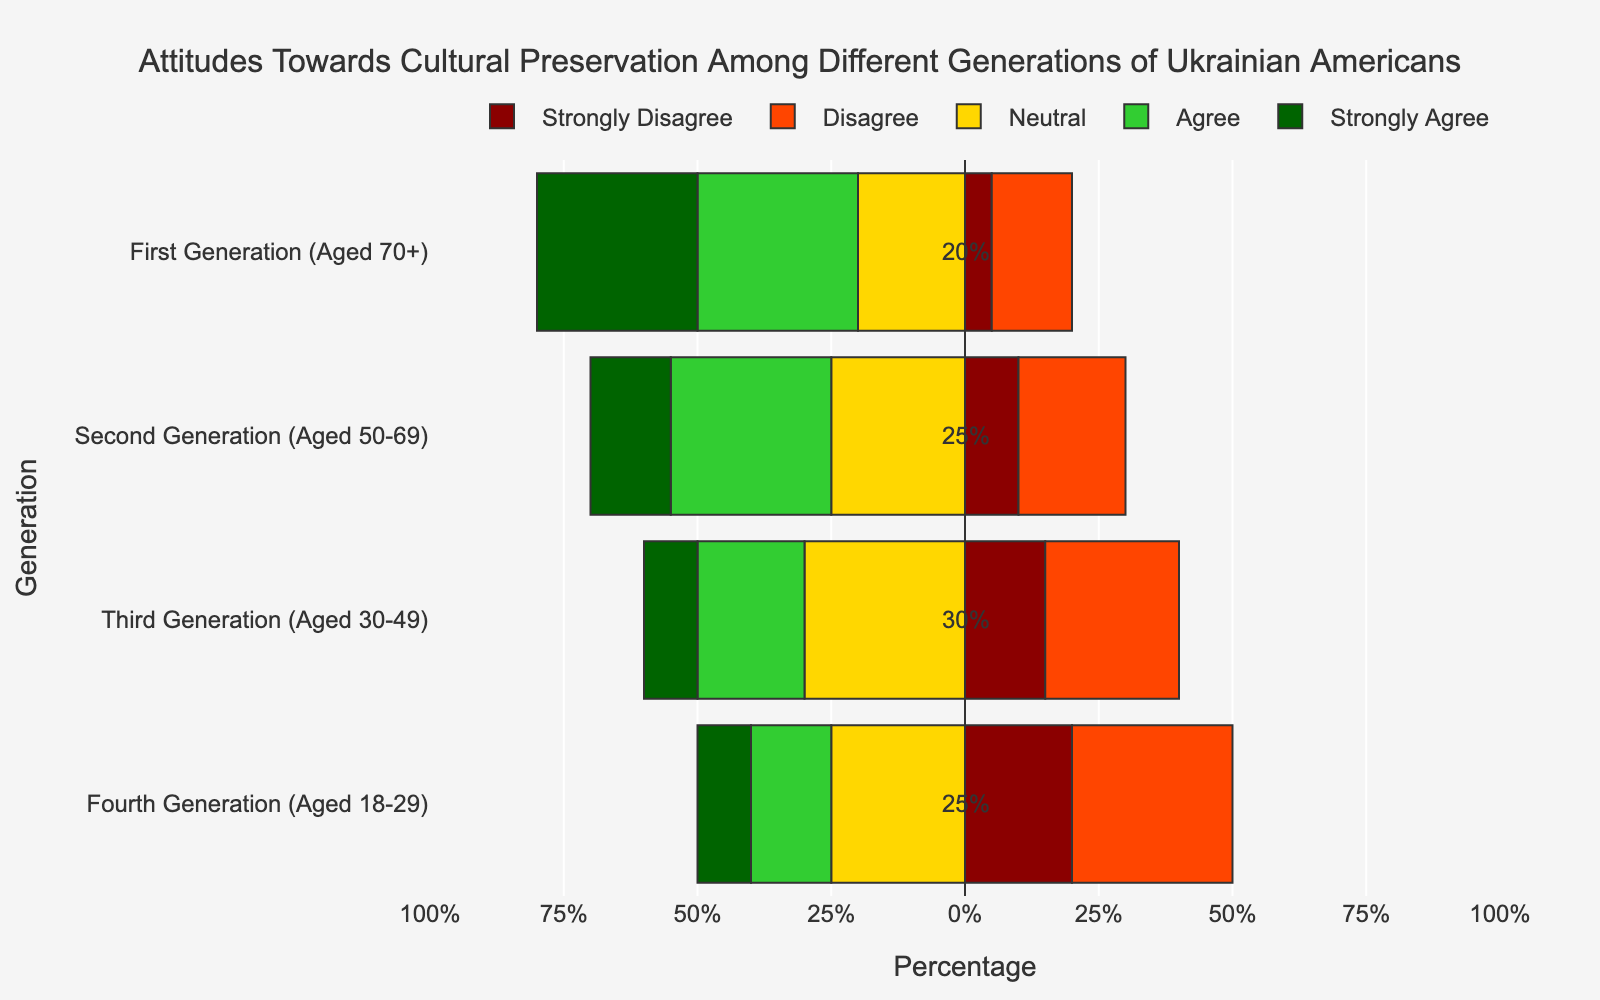What percentage of the Fourth Generation strongly agrees with cultural preservation? First, locate the Fourth Generation on the y-axis. Then observe the bar section representing "Strongly Agree." The length of this section corresponds to 10%.
Answer: 10% How many generations have at least 30% of respondents agreeing or strongly agreeing with cultural preservation? Check each generation to see which ones have "Agree" and "Strongly Agree" sections combined to at least 30%. First Generation (30% + 30% = 60%) and Second Generation (30% + 15% = 45%) meet the criterion.
Answer: Two generations Which generation has the highest percentage of respondents disagreeing with cultural preservation? Observe the "Disagree" sections across all generations. The Fourth Generation has the longest bar for "Disagree," corresponding to 30%.
Answer: Fourth Generation Compare the percentage of respondents from the Third and Fourth Generations who are neutral about cultural preservation. Which is higher? Check the "Neutral" sections for both generations. The Third Generation has 30%, and the Fourth Generation has 25%. Therefore, the Third Generation has a higher percentage.
Answer: Third Generation What is the combined percentage of respondents in the First Generation group who are either neutral or disagree with cultural preservation? For the First Generation, sum the "Neutral" (20%) and "Disagree" (15%) sections. (20% + 15% = 35%)
Answer: 35% Identify the generation with the least percentage of strong disagreement towards cultural preservation and state the percentage. Observe the "Strongly Disagree" sections across all generations. The First Generation has the smallest percentage for "Strongly Disagree" at 5%.
Answer: First Generation with 5% Which generation shows a greater overall disagreement (including both "Disagree" and "Strongly Disagree") compared to the Second Generation? Calculate combined percentages of "Disagree" and "Strongly Disagree" for generations: Fourth Generation (30% + 20% = 50%) vs. Second Generation (20% + 10% = 30%). The Fourth Generation shows greater overall disagreement compared to the Second Generation.
Answer: Fourth Generation 